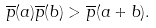Convert formula to latex. <formula><loc_0><loc_0><loc_500><loc_500>\overline { p } ( a ) \overline { p } ( b ) > \overline { p } ( a + b ) .</formula> 